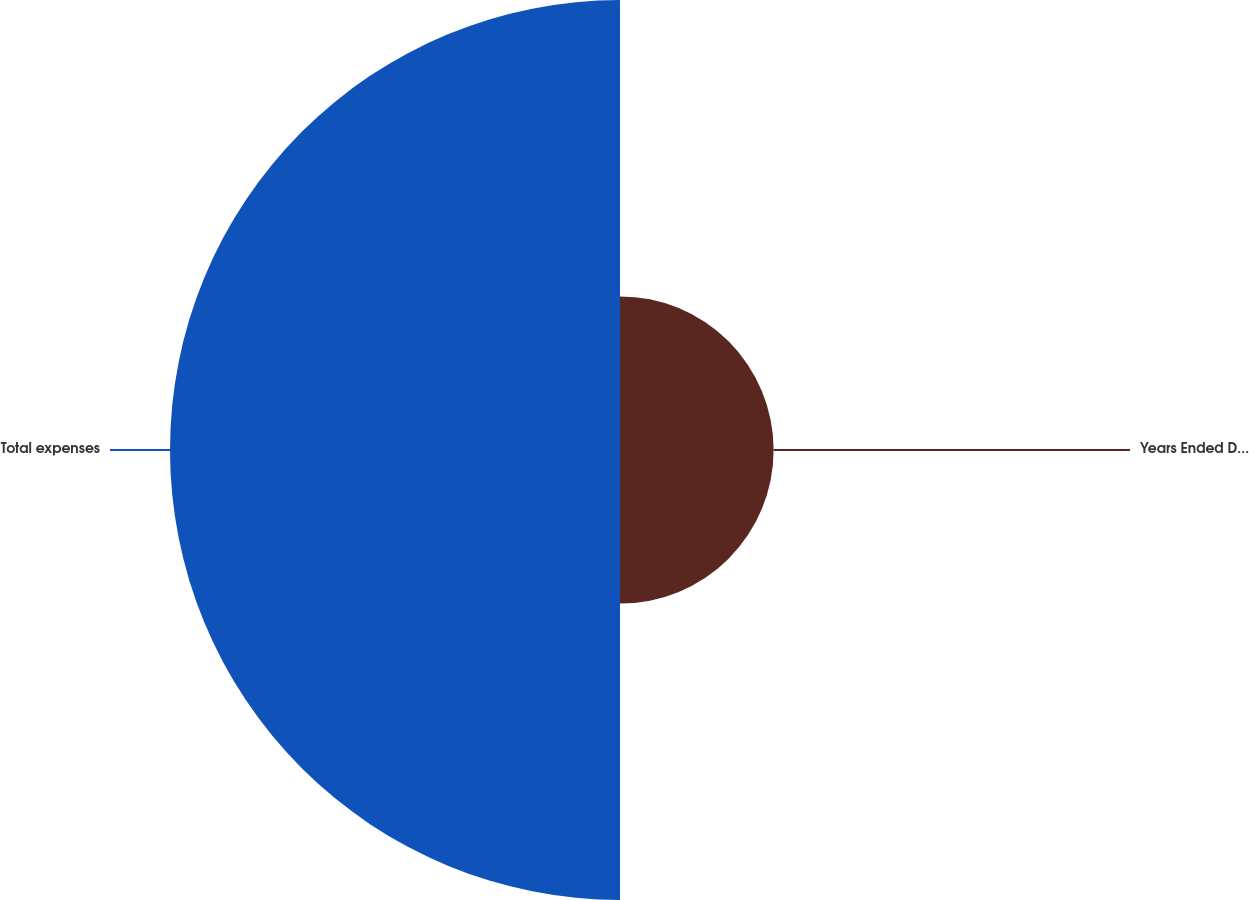Convert chart. <chart><loc_0><loc_0><loc_500><loc_500><pie_chart><fcel>Years Ended December 31<fcel>Total expenses<nl><fcel>25.45%<fcel>74.55%<nl></chart> 